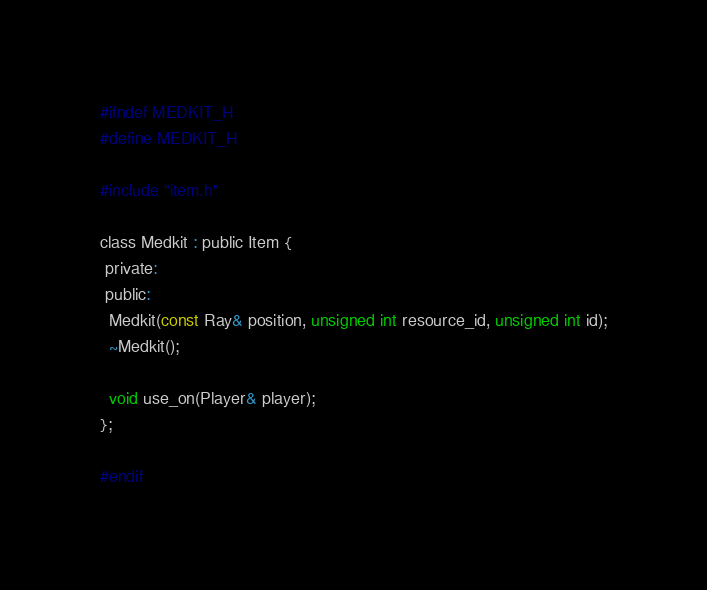<code> <loc_0><loc_0><loc_500><loc_500><_C_>#ifndef MEDKIT_H
#define MEDKIT_H

#include "item.h"

class Medkit : public Item {
 private:
 public:
  Medkit(const Ray& position, unsigned int resource_id, unsigned int id);
  ~Medkit();

  void use_on(Player& player);
};

#endif
</code> 